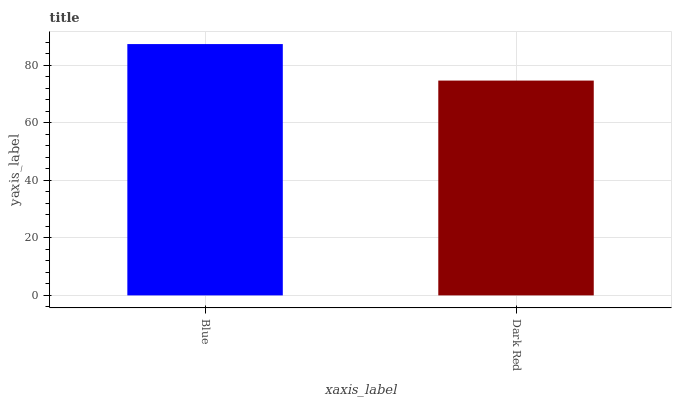Is Dark Red the minimum?
Answer yes or no. Yes. Is Blue the maximum?
Answer yes or no. Yes. Is Dark Red the maximum?
Answer yes or no. No. Is Blue greater than Dark Red?
Answer yes or no. Yes. Is Dark Red less than Blue?
Answer yes or no. Yes. Is Dark Red greater than Blue?
Answer yes or no. No. Is Blue less than Dark Red?
Answer yes or no. No. Is Blue the high median?
Answer yes or no. Yes. Is Dark Red the low median?
Answer yes or no. Yes. Is Dark Red the high median?
Answer yes or no. No. Is Blue the low median?
Answer yes or no. No. 